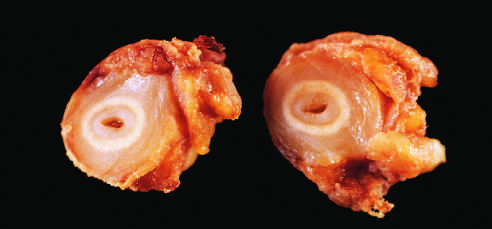what did cross-sections of the right carotid artery from the patient shown in the figure demonstrate?
Answer the question using a single word or phrase. Marked intimal thickening and luminal narrowing 